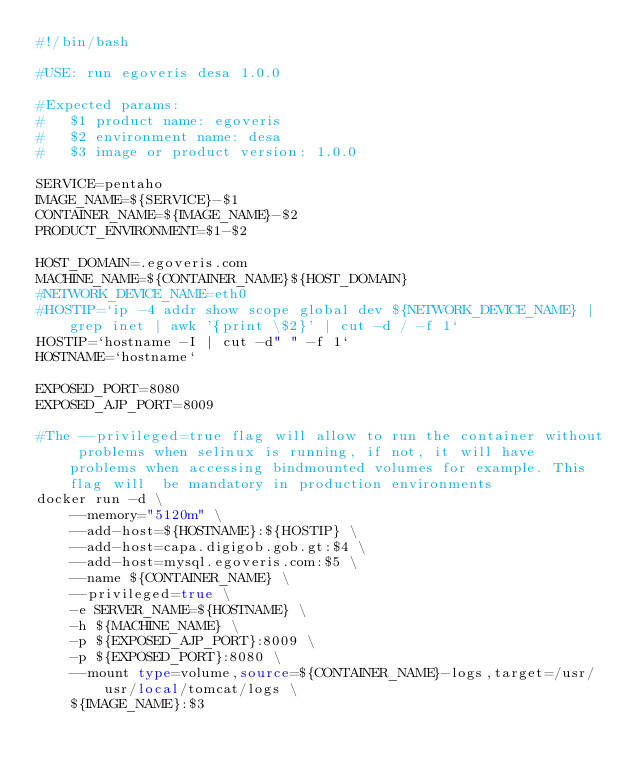<code> <loc_0><loc_0><loc_500><loc_500><_Bash_>#!/bin/bash

#USE: run egoveris desa 1.0.0

#Expected params:
#	$1 product name: egoveris
#	$2 environment name: desa
#	$3 image or product version: 1.0.0

SERVICE=pentaho
IMAGE_NAME=${SERVICE}-$1
CONTAINER_NAME=${IMAGE_NAME}-$2
PRODUCT_ENVIRONMENT=$1-$2

HOST_DOMAIN=.egoveris.com
MACHINE_NAME=${CONTAINER_NAME}${HOST_DOMAIN}
#NETWORK_DEVICE_NAME=eth0
#HOSTIP=`ip -4 addr show scope global dev ${NETWORK_DEVICE_NAME} | grep inet | awk '{print \$2}' | cut -d / -f 1`
HOSTIP=`hostname -I | cut -d" " -f 1`
HOSTNAME=`hostname`

EXPOSED_PORT=8080
EXPOSED_AJP_PORT=8009

#The --privileged=true flag will allow to run the container without problems when selinux is running, if not, it will have problems when accessing bindmounted volumes for example. This flag will  be mandatory in production environments
docker run -d \
	--memory="5120m" \
	--add-host=${HOSTNAME}:${HOSTIP} \
	--add-host=capa.digigob.gob.gt:$4 \
	--add-host=mysql.egoveris.com:$5 \
	--name ${CONTAINER_NAME} \
	--privileged=true \
	-e SERVER_NAME=${HOSTNAME} \
	-h ${MACHINE_NAME} \
	-p ${EXPOSED_AJP_PORT}:8009 \
	-p ${EXPOSED_PORT}:8080 \
	--mount type=volume,source=${CONTAINER_NAME}-logs,target=/usr/usr/local/tomcat/logs \
	${IMAGE_NAME}:$3
</code> 